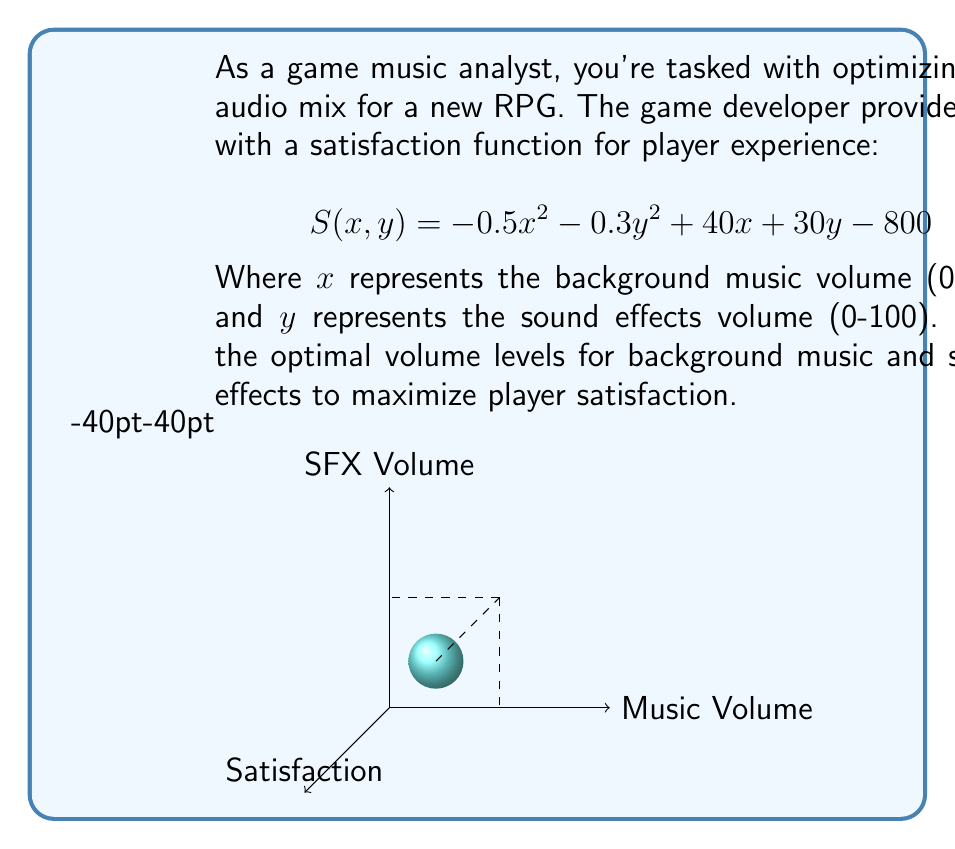Could you help me with this problem? To find the optimal volume levels, we need to maximize the satisfaction function $S(x, y)$. This is a two-variable optimization problem, which we can solve using partial derivatives:

1) Take partial derivatives of $S$ with respect to $x$ and $y$:
   $\frac{\partial S}{\partial x} = -x + 40$
   $\frac{\partial S}{\partial y} = -0.6y + 30$

2) Set both partial derivatives to zero to find critical points:
   $-x + 40 = 0$ and $-0.6y + 30 = 0$

3) Solve these equations:
   $x = 40$ and $y = 50$

4) To confirm this is a maximum, we can check the second derivatives:
   $\frac{\partial^2 S}{\partial x^2} = -1$
   $\frac{\partial^2 S}{\partial y^2} = -0.6$
   Both are negative, confirming a maximum.

5) Check if the solution is within the valid range (0-100):
   $40$ is within $[0, 100]$ for $x$
   $50$ is within $[0, 100]$ for $y$

Therefore, the optimal volume levels are 40 for background music and 50 for sound effects.

6) Calculate the maximum satisfaction:
   $S(40, 50) = -0.5(40)^2 - 0.3(50)^2 + 40(40) + 30(50) - 800 = 1000$
Answer: Background Music: 40, Sound Effects: 50 